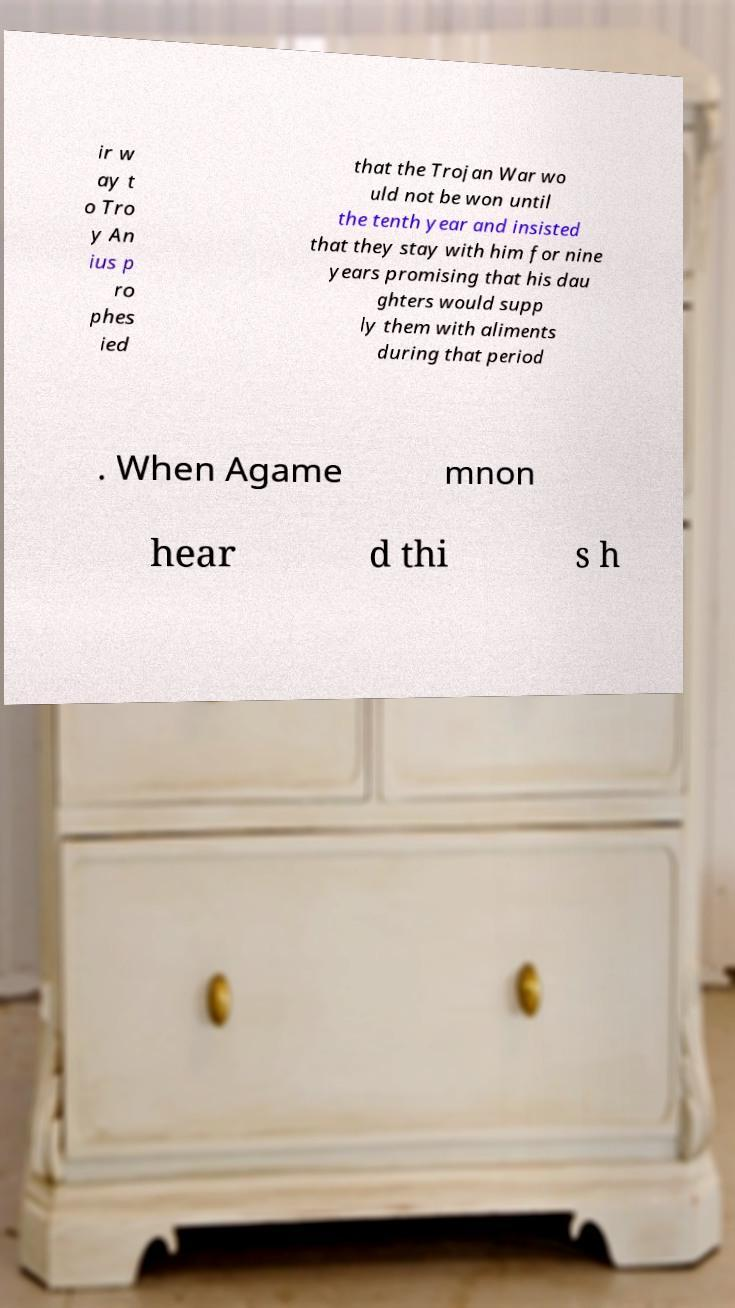Please identify and transcribe the text found in this image. ir w ay t o Tro y An ius p ro phes ied that the Trojan War wo uld not be won until the tenth year and insisted that they stay with him for nine years promising that his dau ghters would supp ly them with aliments during that period . When Agame mnon hear d thi s h 